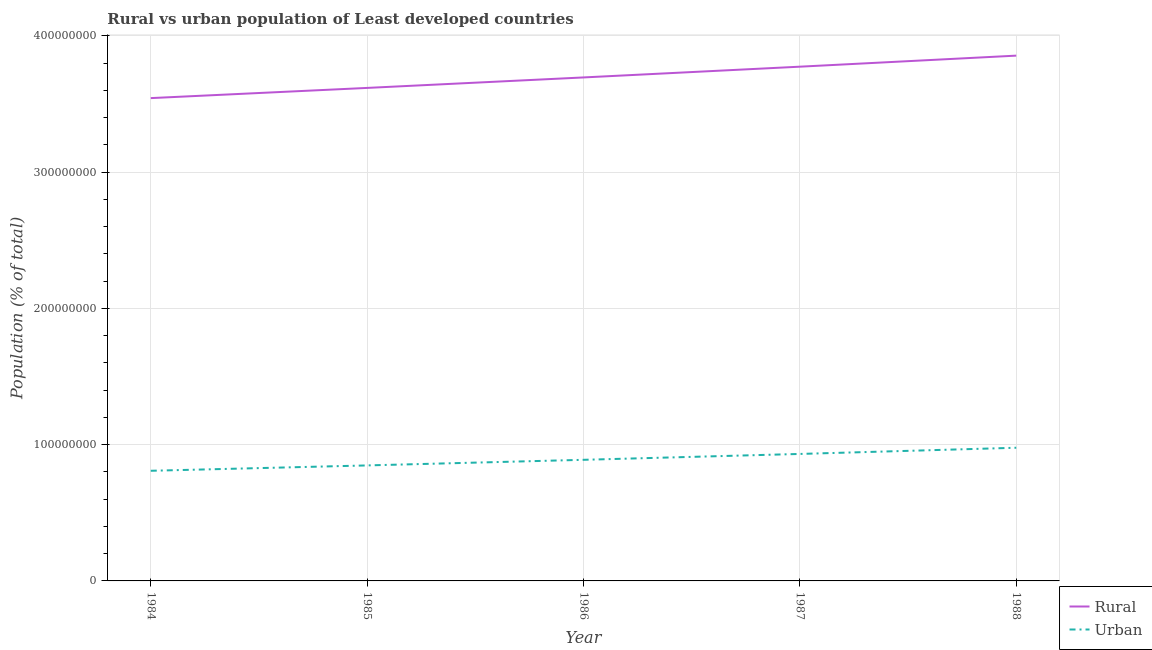How many different coloured lines are there?
Give a very brief answer. 2. Does the line corresponding to urban population density intersect with the line corresponding to rural population density?
Offer a terse response. No. Is the number of lines equal to the number of legend labels?
Your response must be concise. Yes. What is the urban population density in 1988?
Your answer should be very brief. 9.77e+07. Across all years, what is the maximum urban population density?
Provide a short and direct response. 9.77e+07. Across all years, what is the minimum rural population density?
Your answer should be compact. 3.54e+08. In which year was the urban population density minimum?
Ensure brevity in your answer.  1984. What is the total rural population density in the graph?
Give a very brief answer. 1.85e+09. What is the difference between the rural population density in 1986 and that in 1987?
Give a very brief answer. -7.89e+06. What is the difference between the urban population density in 1986 and the rural population density in 1984?
Your answer should be very brief. -2.65e+08. What is the average rural population density per year?
Your answer should be compact. 3.70e+08. In the year 1988, what is the difference between the urban population density and rural population density?
Your answer should be very brief. -2.88e+08. What is the ratio of the urban population density in 1984 to that in 1987?
Your answer should be compact. 0.87. Is the rural population density in 1987 less than that in 1988?
Ensure brevity in your answer.  Yes. What is the difference between the highest and the second highest urban population density?
Offer a very short reply. 4.54e+06. What is the difference between the highest and the lowest urban population density?
Offer a terse response. 1.69e+07. In how many years, is the rural population density greater than the average rural population density taken over all years?
Give a very brief answer. 2. Does the rural population density monotonically increase over the years?
Your answer should be very brief. Yes. How many lines are there?
Offer a very short reply. 2. How many years are there in the graph?
Keep it short and to the point. 5. What is the difference between two consecutive major ticks on the Y-axis?
Make the answer very short. 1.00e+08. Are the values on the major ticks of Y-axis written in scientific E-notation?
Give a very brief answer. No. Does the graph contain any zero values?
Provide a short and direct response. No. Does the graph contain grids?
Offer a terse response. Yes. Where does the legend appear in the graph?
Your answer should be compact. Bottom right. How many legend labels are there?
Make the answer very short. 2. How are the legend labels stacked?
Your response must be concise. Vertical. What is the title of the graph?
Give a very brief answer. Rural vs urban population of Least developed countries. Does "US$" appear as one of the legend labels in the graph?
Offer a very short reply. No. What is the label or title of the X-axis?
Your response must be concise. Year. What is the label or title of the Y-axis?
Ensure brevity in your answer.  Population (% of total). What is the Population (% of total) in Rural in 1984?
Offer a terse response. 3.54e+08. What is the Population (% of total) of Urban in 1984?
Offer a very short reply. 8.08e+07. What is the Population (% of total) in Rural in 1985?
Keep it short and to the point. 3.62e+08. What is the Population (% of total) of Urban in 1985?
Make the answer very short. 8.48e+07. What is the Population (% of total) in Rural in 1986?
Provide a succinct answer. 3.69e+08. What is the Population (% of total) in Urban in 1986?
Your answer should be compact. 8.89e+07. What is the Population (% of total) in Rural in 1987?
Provide a short and direct response. 3.77e+08. What is the Population (% of total) in Urban in 1987?
Keep it short and to the point. 9.32e+07. What is the Population (% of total) of Rural in 1988?
Provide a short and direct response. 3.85e+08. What is the Population (% of total) of Urban in 1988?
Provide a succinct answer. 9.77e+07. Across all years, what is the maximum Population (% of total) in Rural?
Offer a very short reply. 3.85e+08. Across all years, what is the maximum Population (% of total) in Urban?
Make the answer very short. 9.77e+07. Across all years, what is the minimum Population (% of total) in Rural?
Give a very brief answer. 3.54e+08. Across all years, what is the minimum Population (% of total) of Urban?
Your answer should be very brief. 8.08e+07. What is the total Population (% of total) of Rural in the graph?
Provide a short and direct response. 1.85e+09. What is the total Population (% of total) of Urban in the graph?
Offer a very short reply. 4.45e+08. What is the difference between the Population (% of total) of Rural in 1984 and that in 1985?
Ensure brevity in your answer.  -7.48e+06. What is the difference between the Population (% of total) of Urban in 1984 and that in 1985?
Offer a very short reply. -3.93e+06. What is the difference between the Population (% of total) of Rural in 1984 and that in 1986?
Offer a very short reply. -1.52e+07. What is the difference between the Population (% of total) of Urban in 1984 and that in 1986?
Your response must be concise. -8.05e+06. What is the difference between the Population (% of total) of Rural in 1984 and that in 1987?
Your answer should be compact. -2.31e+07. What is the difference between the Population (% of total) in Urban in 1984 and that in 1987?
Your response must be concise. -1.24e+07. What is the difference between the Population (% of total) in Rural in 1984 and that in 1988?
Keep it short and to the point. -3.12e+07. What is the difference between the Population (% of total) of Urban in 1984 and that in 1988?
Your answer should be very brief. -1.69e+07. What is the difference between the Population (% of total) of Rural in 1985 and that in 1986?
Ensure brevity in your answer.  -7.69e+06. What is the difference between the Population (% of total) of Urban in 1985 and that in 1986?
Ensure brevity in your answer.  -4.12e+06. What is the difference between the Population (% of total) in Rural in 1985 and that in 1987?
Your answer should be very brief. -1.56e+07. What is the difference between the Population (% of total) in Urban in 1985 and that in 1987?
Your response must be concise. -8.43e+06. What is the difference between the Population (% of total) in Rural in 1985 and that in 1988?
Make the answer very short. -2.37e+07. What is the difference between the Population (% of total) of Urban in 1985 and that in 1988?
Provide a short and direct response. -1.30e+07. What is the difference between the Population (% of total) in Rural in 1986 and that in 1987?
Give a very brief answer. -7.89e+06. What is the difference between the Population (% of total) of Urban in 1986 and that in 1987?
Keep it short and to the point. -4.31e+06. What is the difference between the Population (% of total) in Rural in 1986 and that in 1988?
Ensure brevity in your answer.  -1.60e+07. What is the difference between the Population (% of total) of Urban in 1986 and that in 1988?
Your answer should be compact. -8.85e+06. What is the difference between the Population (% of total) of Rural in 1987 and that in 1988?
Make the answer very short. -8.11e+06. What is the difference between the Population (% of total) of Urban in 1987 and that in 1988?
Keep it short and to the point. -4.54e+06. What is the difference between the Population (% of total) in Rural in 1984 and the Population (% of total) in Urban in 1985?
Provide a short and direct response. 2.70e+08. What is the difference between the Population (% of total) of Rural in 1984 and the Population (% of total) of Urban in 1986?
Your answer should be compact. 2.65e+08. What is the difference between the Population (% of total) in Rural in 1984 and the Population (% of total) in Urban in 1987?
Provide a short and direct response. 2.61e+08. What is the difference between the Population (% of total) of Rural in 1984 and the Population (% of total) of Urban in 1988?
Offer a very short reply. 2.57e+08. What is the difference between the Population (% of total) in Rural in 1985 and the Population (% of total) in Urban in 1986?
Offer a terse response. 2.73e+08. What is the difference between the Population (% of total) of Rural in 1985 and the Population (% of total) of Urban in 1987?
Keep it short and to the point. 2.69e+08. What is the difference between the Population (% of total) of Rural in 1985 and the Population (% of total) of Urban in 1988?
Offer a very short reply. 2.64e+08. What is the difference between the Population (% of total) in Rural in 1986 and the Population (% of total) in Urban in 1987?
Ensure brevity in your answer.  2.76e+08. What is the difference between the Population (% of total) of Rural in 1986 and the Population (% of total) of Urban in 1988?
Provide a succinct answer. 2.72e+08. What is the difference between the Population (% of total) of Rural in 1987 and the Population (% of total) of Urban in 1988?
Keep it short and to the point. 2.80e+08. What is the average Population (% of total) in Rural per year?
Provide a short and direct response. 3.70e+08. What is the average Population (% of total) in Urban per year?
Ensure brevity in your answer.  8.91e+07. In the year 1984, what is the difference between the Population (% of total) of Rural and Population (% of total) of Urban?
Offer a very short reply. 2.73e+08. In the year 1985, what is the difference between the Population (% of total) in Rural and Population (% of total) in Urban?
Make the answer very short. 2.77e+08. In the year 1986, what is the difference between the Population (% of total) in Rural and Population (% of total) in Urban?
Provide a succinct answer. 2.81e+08. In the year 1987, what is the difference between the Population (% of total) in Rural and Population (% of total) in Urban?
Your answer should be compact. 2.84e+08. In the year 1988, what is the difference between the Population (% of total) of Rural and Population (% of total) of Urban?
Your answer should be very brief. 2.88e+08. What is the ratio of the Population (% of total) of Rural in 1984 to that in 1985?
Keep it short and to the point. 0.98. What is the ratio of the Population (% of total) of Urban in 1984 to that in 1985?
Keep it short and to the point. 0.95. What is the ratio of the Population (% of total) in Rural in 1984 to that in 1986?
Provide a succinct answer. 0.96. What is the ratio of the Population (% of total) of Urban in 1984 to that in 1986?
Give a very brief answer. 0.91. What is the ratio of the Population (% of total) of Rural in 1984 to that in 1987?
Keep it short and to the point. 0.94. What is the ratio of the Population (% of total) of Urban in 1984 to that in 1987?
Ensure brevity in your answer.  0.87. What is the ratio of the Population (% of total) of Rural in 1984 to that in 1988?
Your answer should be compact. 0.92. What is the ratio of the Population (% of total) of Urban in 1984 to that in 1988?
Offer a very short reply. 0.83. What is the ratio of the Population (% of total) in Rural in 1985 to that in 1986?
Your response must be concise. 0.98. What is the ratio of the Population (% of total) of Urban in 1985 to that in 1986?
Keep it short and to the point. 0.95. What is the ratio of the Population (% of total) of Rural in 1985 to that in 1987?
Your answer should be very brief. 0.96. What is the ratio of the Population (% of total) of Urban in 1985 to that in 1987?
Your answer should be very brief. 0.91. What is the ratio of the Population (% of total) of Rural in 1985 to that in 1988?
Provide a succinct answer. 0.94. What is the ratio of the Population (% of total) in Urban in 1985 to that in 1988?
Keep it short and to the point. 0.87. What is the ratio of the Population (% of total) of Rural in 1986 to that in 1987?
Offer a very short reply. 0.98. What is the ratio of the Population (% of total) of Urban in 1986 to that in 1987?
Your answer should be very brief. 0.95. What is the ratio of the Population (% of total) in Rural in 1986 to that in 1988?
Your answer should be compact. 0.96. What is the ratio of the Population (% of total) in Urban in 1986 to that in 1988?
Provide a short and direct response. 0.91. What is the ratio of the Population (% of total) in Urban in 1987 to that in 1988?
Your answer should be very brief. 0.95. What is the difference between the highest and the second highest Population (% of total) in Rural?
Provide a short and direct response. 8.11e+06. What is the difference between the highest and the second highest Population (% of total) of Urban?
Make the answer very short. 4.54e+06. What is the difference between the highest and the lowest Population (% of total) of Rural?
Offer a terse response. 3.12e+07. What is the difference between the highest and the lowest Population (% of total) of Urban?
Offer a terse response. 1.69e+07. 